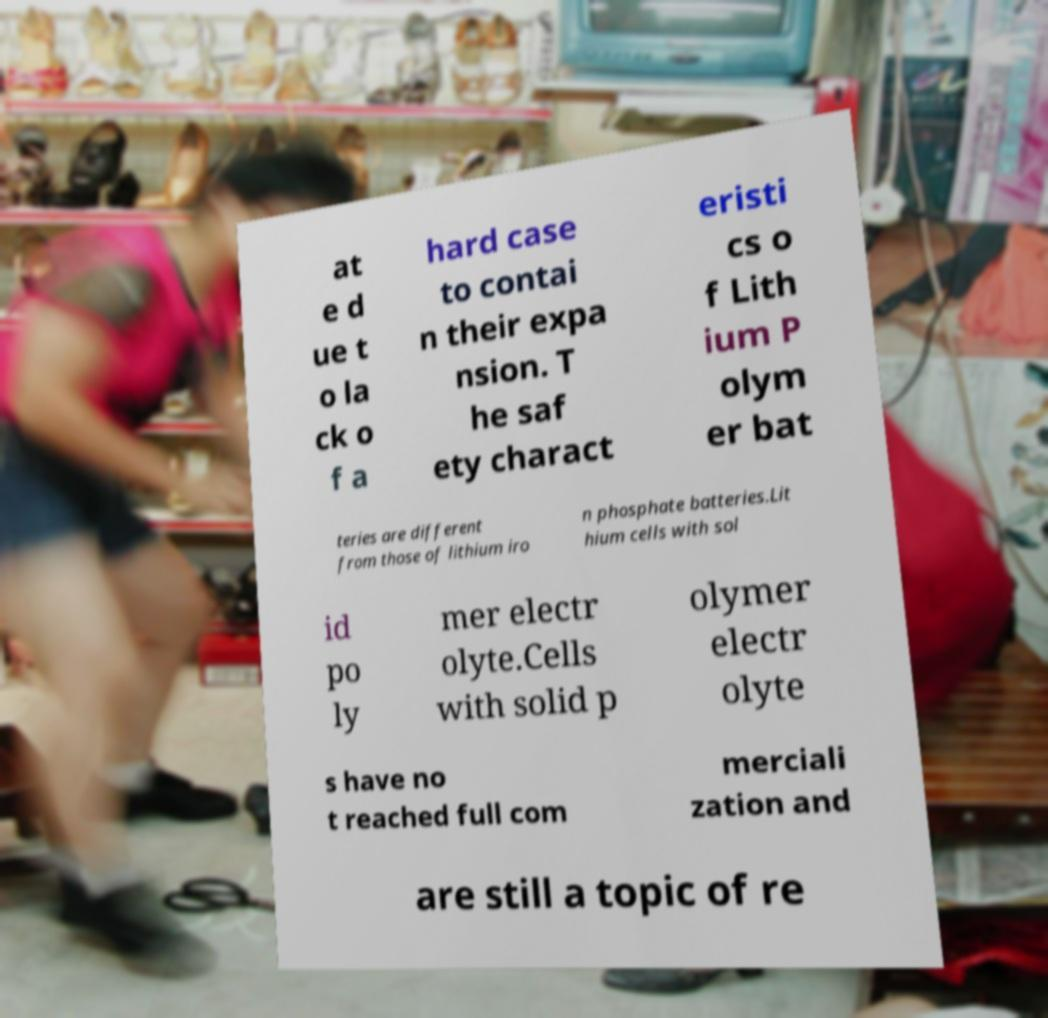Could you assist in decoding the text presented in this image and type it out clearly? at e d ue t o la ck o f a hard case to contai n their expa nsion. T he saf ety charact eristi cs o f Lith ium P olym er bat teries are different from those of lithium iro n phosphate batteries.Lit hium cells with sol id po ly mer electr olyte.Cells with solid p olymer electr olyte s have no t reached full com merciali zation and are still a topic of re 